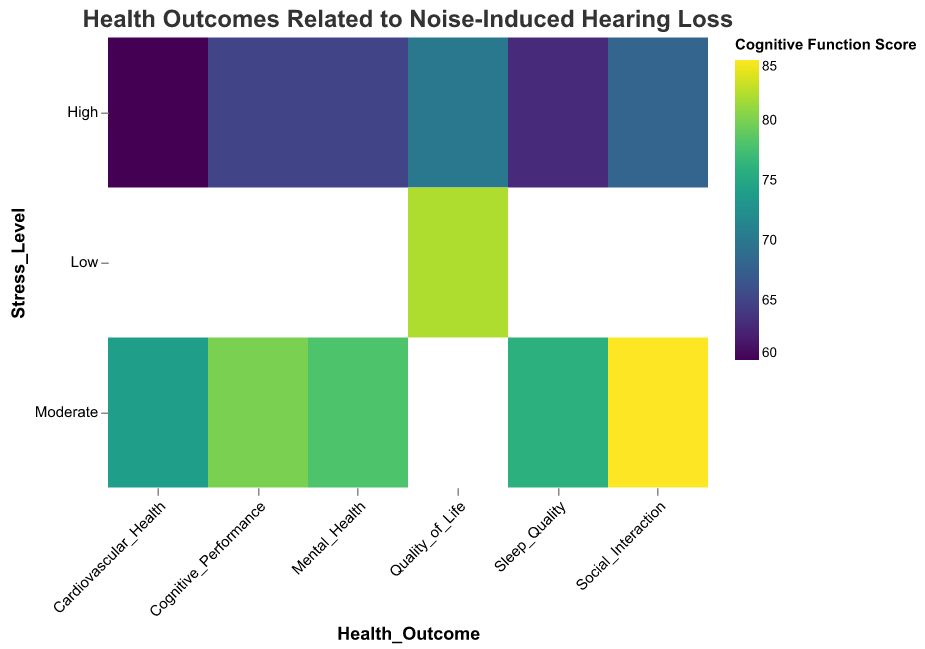What health outcome is associated with the highest cognitive function score? The highest cognitive function score is 85, associated with moderate stress level social interaction.
Answer: Social Interaction Which health outcome shows the highest stress level? The highest stress level is 'High', associated with several health outcomes including Cardiovascular Health, Mental Health, Quality of Life, Cognitive Performance, Sleep Quality, and Social Interaction.
Answer: Multiple outcomes How does tinnitus severity vary with different health outcomes? By hovering over each health outcome, we can see the associated tinnitus severity. For example, severe tinnitus is seen with Cardiovascular Health, Mental Health, Quality of Life, Sleep Quality, and Social Interaction when stress levels are high.
Answer: Varies by outcome What's the most common stress level among all health outcomes? By observing the y-axis, 'High' appears more frequently across different health outcomes compared to 'Moderate' and 'Low'.
Answer: High Which health outcome has been exposed for the longest duration? By looking at the tooltip for duration of exposure, Cognitive Performance shows the longest exposure of 22 years with high stress level.
Answer: Cognitive Performance Which stress level results in the highest cognitive function score for Cognitive Performance? By examining Cognitive Performance, the highest score is 80, which is associated with moderate stress level.
Answer: Moderate Is there a correlation between stress level and cognitive function score across health outcomes? By comparing the color shades, high stress levels generally show lower cognitive function scores, suggesting a negative correlation.
Answer: Yes, negative correlation Which health outcome has the highest cognitive function score with severe tinnitus severity? By examining the tooltip for scores and tinnitus severity, Social Interaction with moderate stress has the highest cognitive function score of 85.
Answer: Social Interaction Between Cardiovascular Health and Mental Health, which has a lower cognitive function score with high stress? Cardiovascular Health has a score of 60 while Mental Health has a score of 65 under high stress conditions.
Answer: Cardiovascular Health How does the cognitive function score differ between high and low stress levels for Quality of Life? For Quality of Life, high stress level shows a cognitive function score of 70 while low stress level shows 82, indicating a decrease in score with higher stress.
Answer: Decrease 